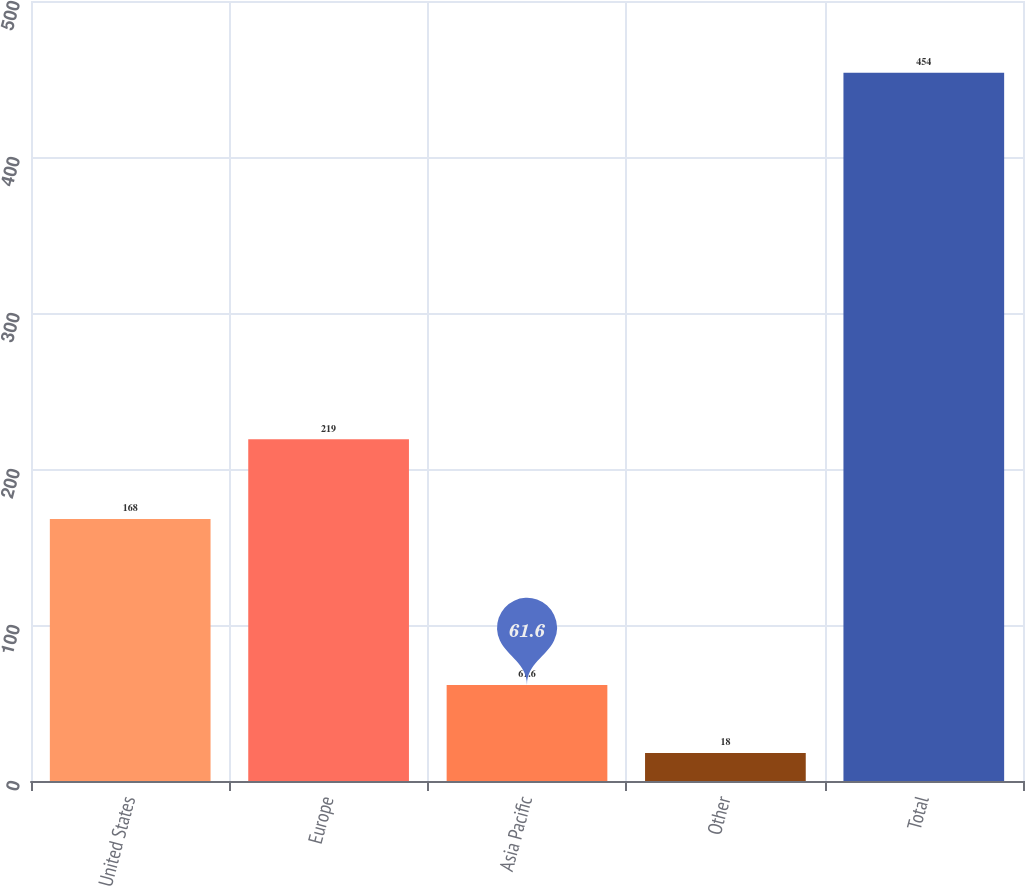<chart> <loc_0><loc_0><loc_500><loc_500><bar_chart><fcel>United States<fcel>Europe<fcel>Asia Pacific<fcel>Other<fcel>Total<nl><fcel>168<fcel>219<fcel>61.6<fcel>18<fcel>454<nl></chart> 